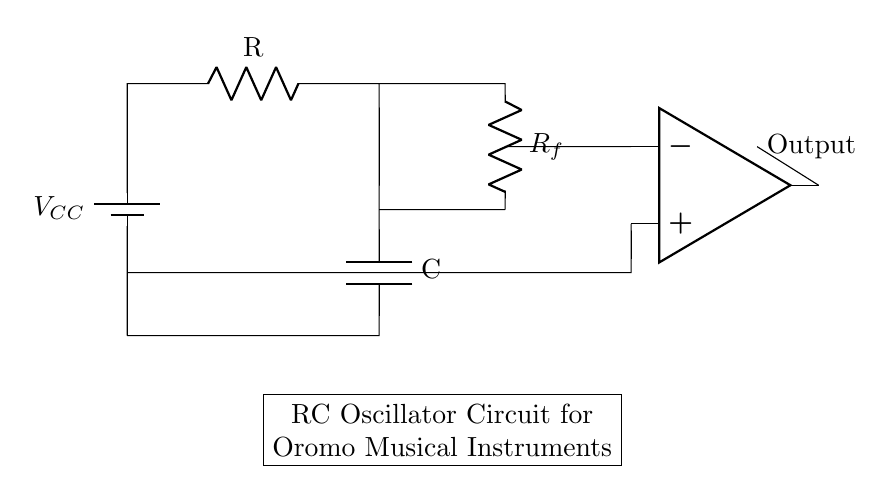What is the component that stores energy in this circuit? The circuit includes a capacitor, which is denoted by the symbol "C". Capacitors store energy in the form of an electric field.
Answer: Capacitor What is the function of the resistor in this RC oscillator? The resistor affects the charging and discharging time of the capacitor, influencing the frequency of oscillation in the circuit. The resistor value determines the time constant.
Answer: Time constant What is the voltage supply of this circuit? The circuit shows a battery labeled with the symbol "VCC", which represents the voltage supply provided to the circuit.
Answer: VCC What is the primary role of the operational amplifier in this circuit? The operational amplifier enhances the signal from the RC network, providing the necessary feedback to sustain oscillation. It acts as a comparator and amplifier.
Answer: Amplifier How does the feedback resistor R_f affect the circuit's operation? The feedback resistor R_f determines the gain of the operational amplifier and influences the stability and frequency of oscillation. A larger R_f increases gain and may lead to sustained oscillations.
Answer: Gain What is the output of this RC oscillator circuit? The output is labeled as "Output" from the operational amplifier, indicating that the circuit generates oscillations that can be used as a tone, especially relevant in musical applications.
Answer: Output 